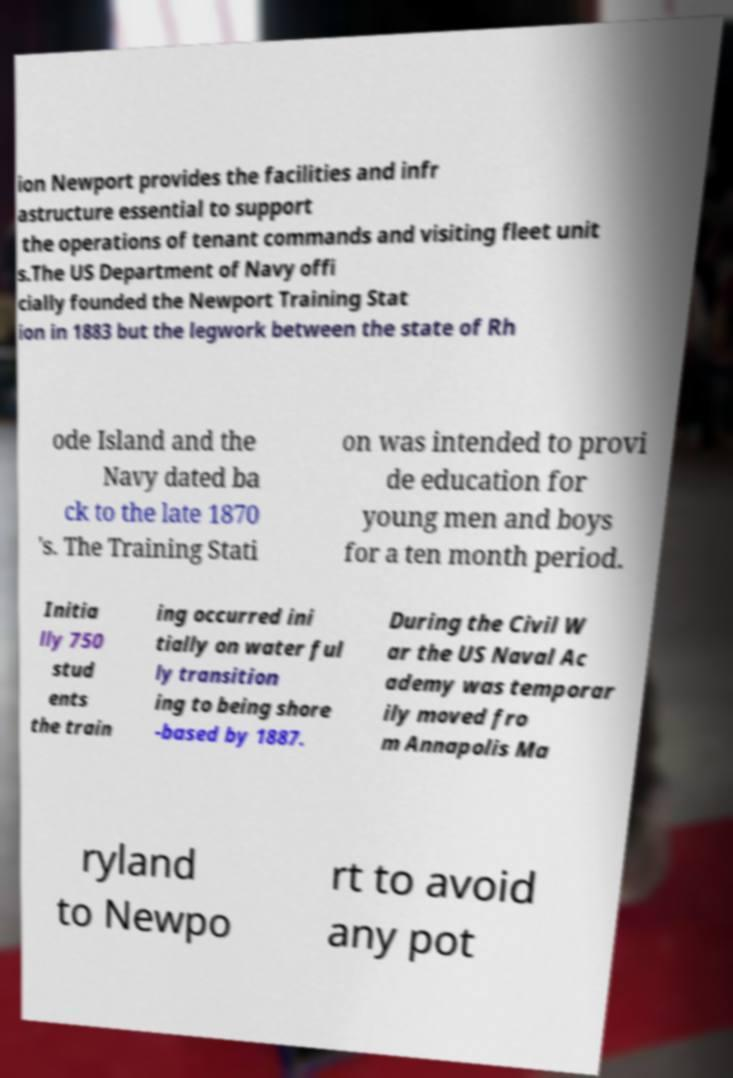There's text embedded in this image that I need extracted. Can you transcribe it verbatim? ion Newport provides the facilities and infr astructure essential to support the operations of tenant commands and visiting fleet unit s.The US Department of Navy offi cially founded the Newport Training Stat ion in 1883 but the legwork between the state of Rh ode Island and the Navy dated ba ck to the late 1870 's. The Training Stati on was intended to provi de education for young men and boys for a ten month period. Initia lly 750 stud ents the train ing occurred ini tially on water ful ly transition ing to being shore -based by 1887. During the Civil W ar the US Naval Ac ademy was temporar ily moved fro m Annapolis Ma ryland to Newpo rt to avoid any pot 